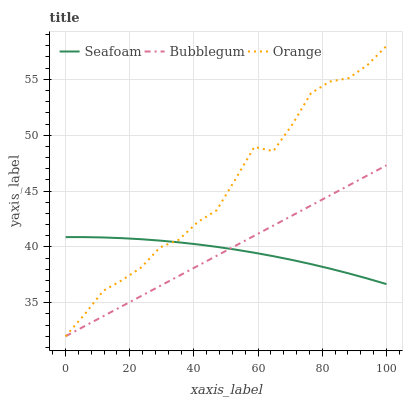Does Bubblegum have the minimum area under the curve?
Answer yes or no. No. Does Bubblegum have the maximum area under the curve?
Answer yes or no. No. Is Seafoam the smoothest?
Answer yes or no. No. Is Seafoam the roughest?
Answer yes or no. No. Does Seafoam have the lowest value?
Answer yes or no. No. Does Bubblegum have the highest value?
Answer yes or no. No. 